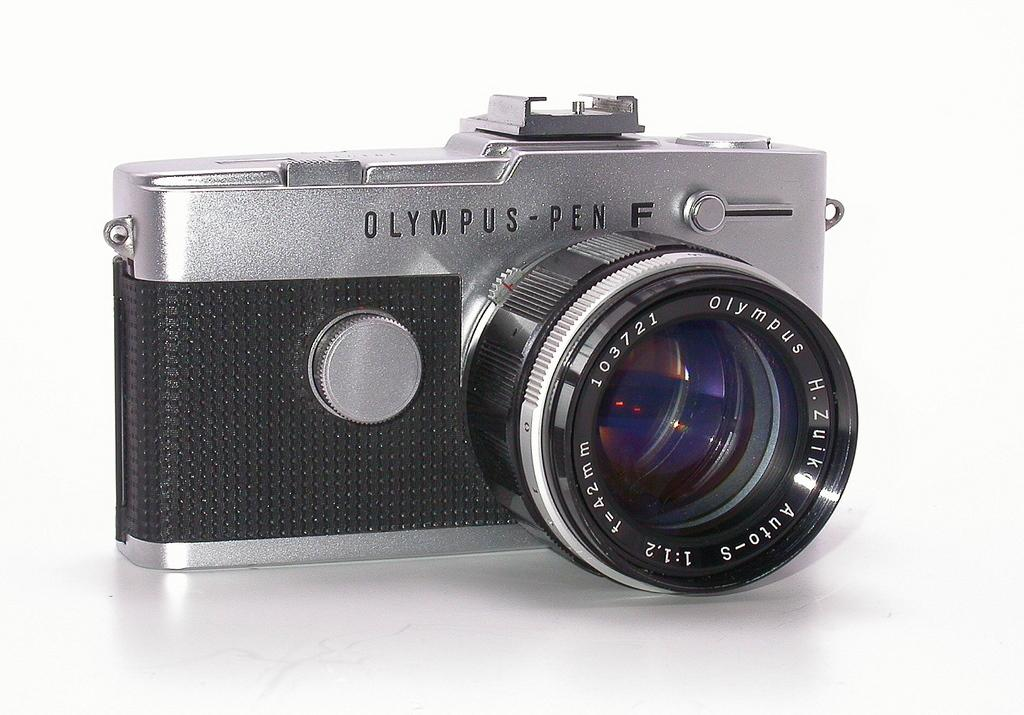What object is the main subject of the image? There is a camera in the image. What is the color of the camera? The camera is gray and black in color. Where is the camera placed in the image? The camera is on a white surface. What additional detail can be seen on the camera? There is text on the camera. What type of game is being played on the camera in the image? There is no game being played on the camera in the image; it is a still object with text on it. How many competitors are participating in the competition depicted in the image? There is no competition depicted in the image; it features a camera on a white surface with text. 